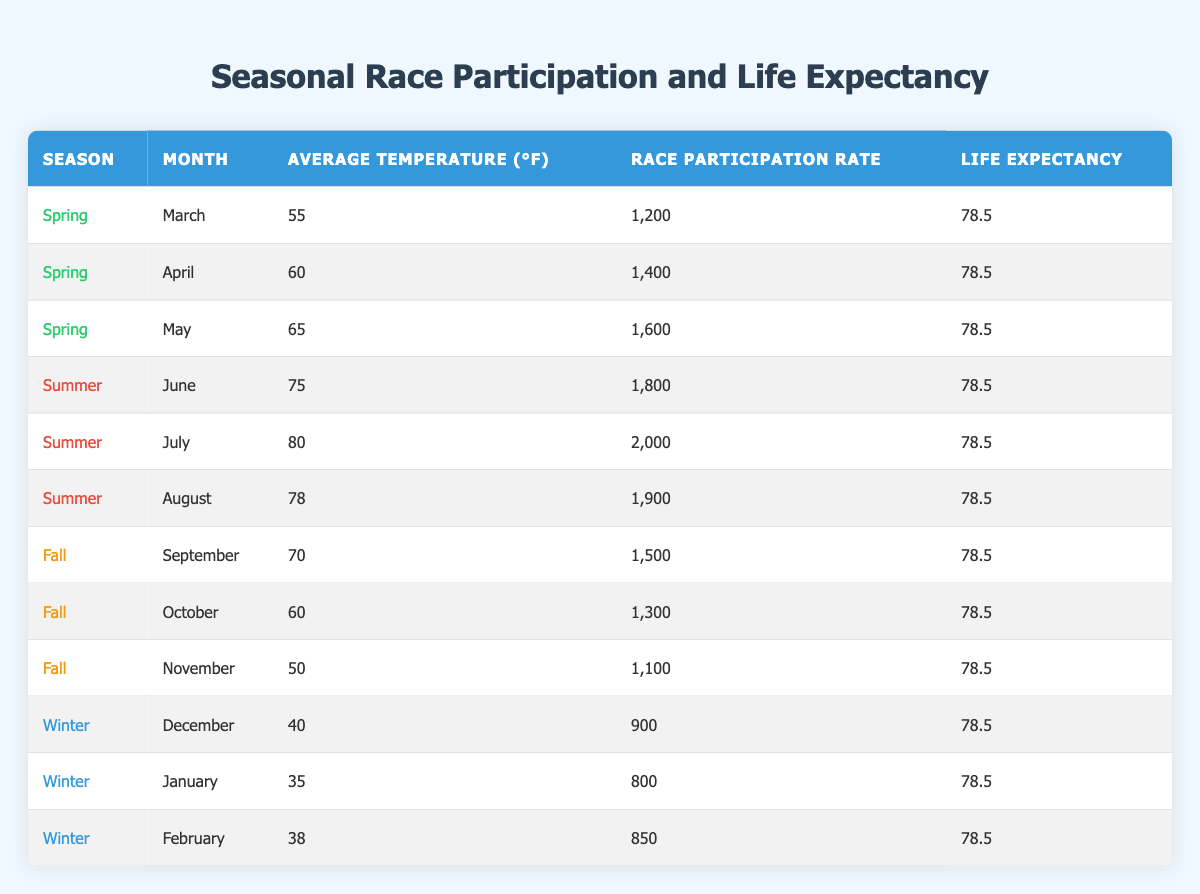What is the race participation rate in July? The table shows that in July, under the Summer season, the race participation rate is listed next to the month. Specifically, it states that the race participation rate for July is 2000.
Answer: 2000 In which month is the average temperature the highest? By looking at the Average Temperature column in the table, we can see that July has the highest average temperature listed at 80°F, which is higher than any other month.
Answer: July Is the life expectancy the same for all seasons? The Life Expectancy column in the table consistently lists the same value of 78.5 for all seasons and months. Therefore, life expectancy does not vary across the seasons.
Answer: Yes What is the total race participation rate from October to February? To find the total race participation rate from October to February, we need to sum the participation rates for October (1300), November (1100), December (900), January (800), and February (850). Calculating this results in 1300 + 1100 + 900 + 800 + 850 = 5050.
Answer: 5050 Which season has the lowest race participation rate? Looking at the Race Participation Rate column, the lowest value is 800, which corresponds to January during the Winter season, indicating that Winter has the lowest participation rate.
Answer: Winter What is the average temperature for the Spring months? To find the average temperature for the Spring months (March, April, and May), we add the average temperatures: 55 (March) + 60 (April) + 65 (May) = 180°F. Then, we divide by the number of months (3) to get the average: 180/3 = 60°F.
Answer: 60°F Does race participation increase or decrease as the seasons change from Winter to Summer? By comparing the numbers, we see that Winter shows lower participation rates (e.g., January has 800) compared to Summer months (e.g., July has 2000). This indicates an increase in race participation as the seasons change from Winter to Summer.
Answer: Increase In which month does the average temperature drop below 40°F? Based on the table, January has the lowest average temperature listed, which is 35°F. It is the only month in the table with a temperature below 40°F.
Answer: January 